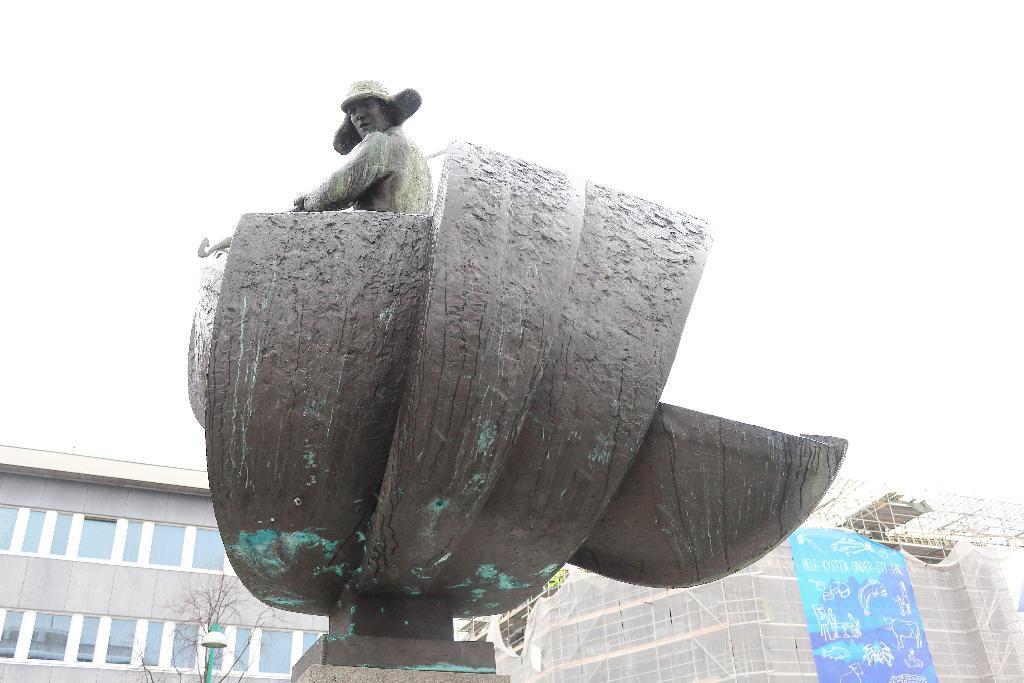Could you give a brief overview of what you see in this image? In the background we can see buildings, bare tree, light with a pole. This is a banner in blue color. Here we can see the statue of a man. 